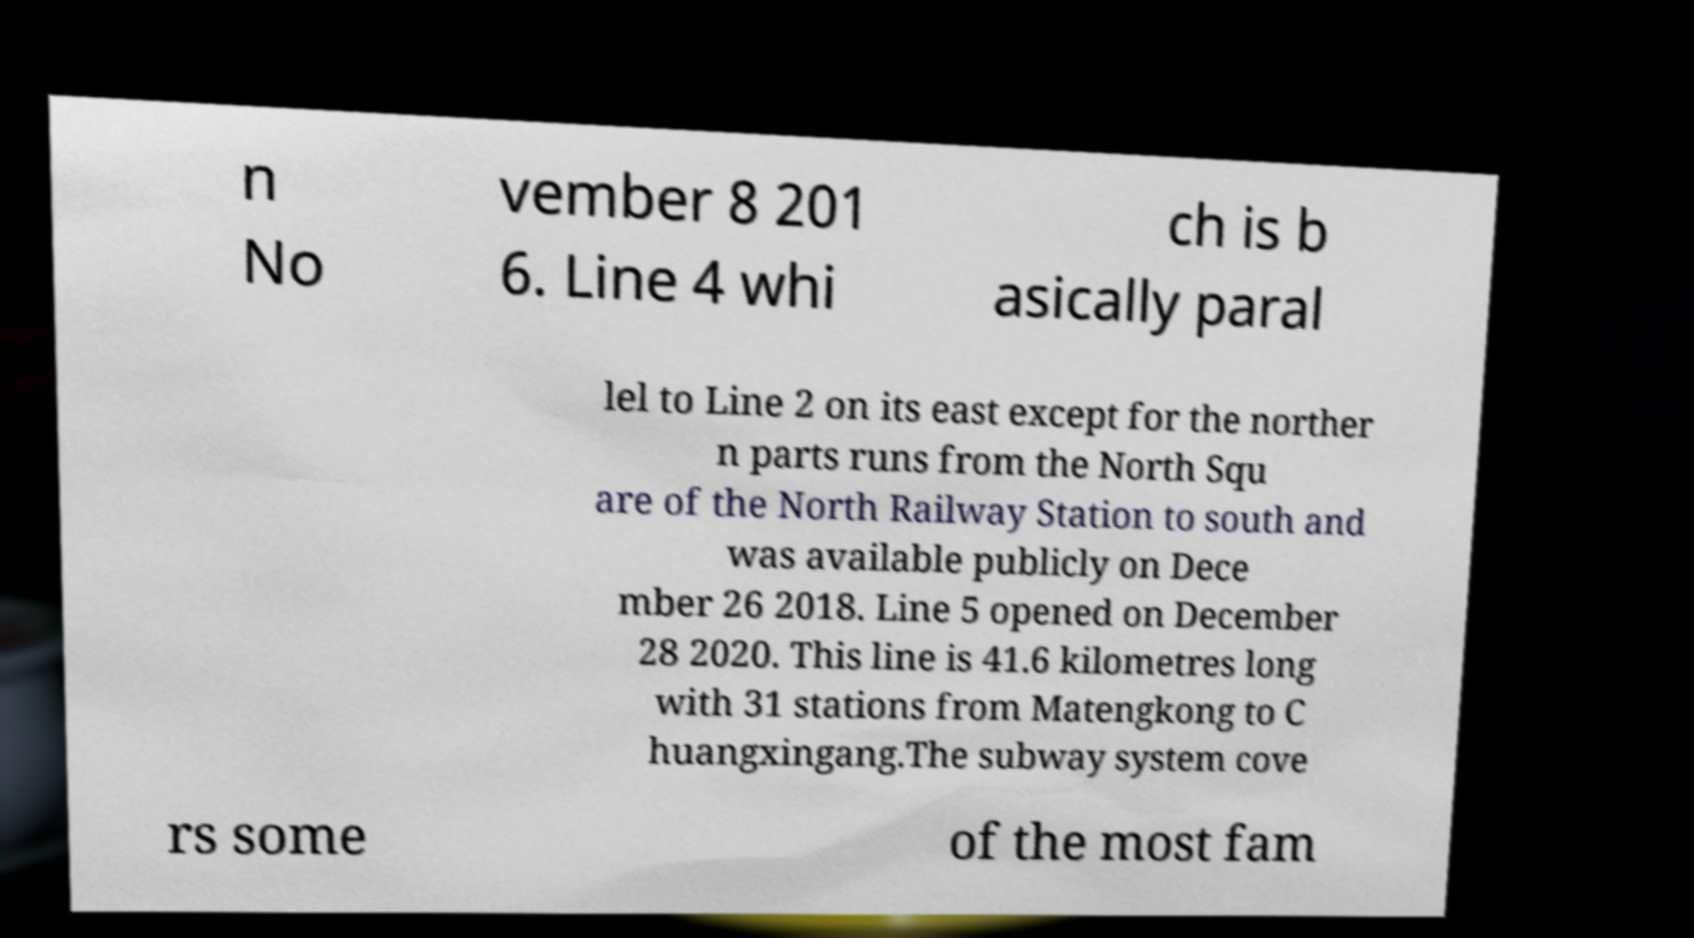What messages or text are displayed in this image? I need them in a readable, typed format. n No vember 8 201 6. Line 4 whi ch is b asically paral lel to Line 2 on its east except for the norther n parts runs from the North Squ are of the North Railway Station to south and was available publicly on Dece mber 26 2018. Line 5 opened on December 28 2020. This line is 41.6 kilometres long with 31 stations from Matengkong to C huangxingang.The subway system cove rs some of the most fam 